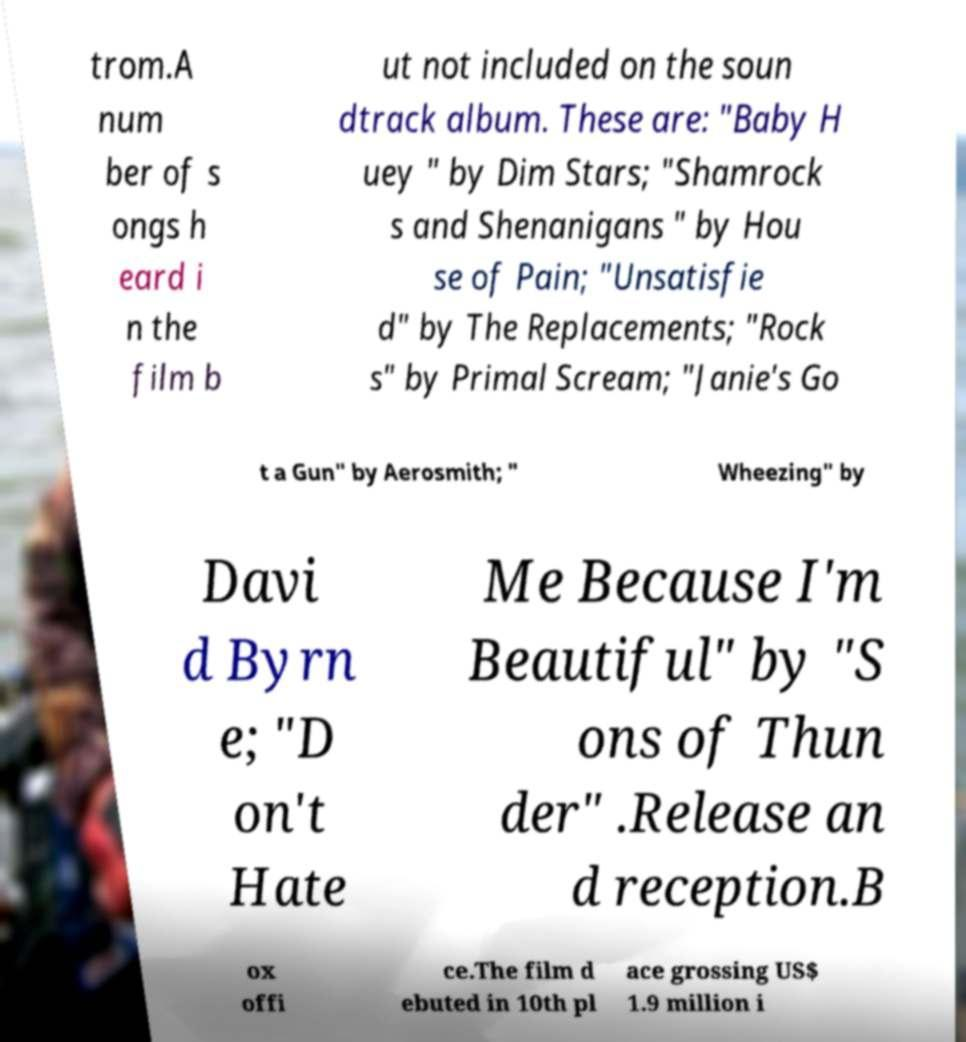Could you extract and type out the text from this image? trom.A num ber of s ongs h eard i n the film b ut not included on the soun dtrack album. These are: "Baby H uey " by Dim Stars; "Shamrock s and Shenanigans " by Hou se of Pain; "Unsatisfie d" by The Replacements; "Rock s" by Primal Scream; "Janie's Go t a Gun" by Aerosmith; " Wheezing" by Davi d Byrn e; "D on't Hate Me Because I'm Beautiful" by "S ons of Thun der" .Release an d reception.B ox offi ce.The film d ebuted in 10th pl ace grossing US$ 1.9 million i 